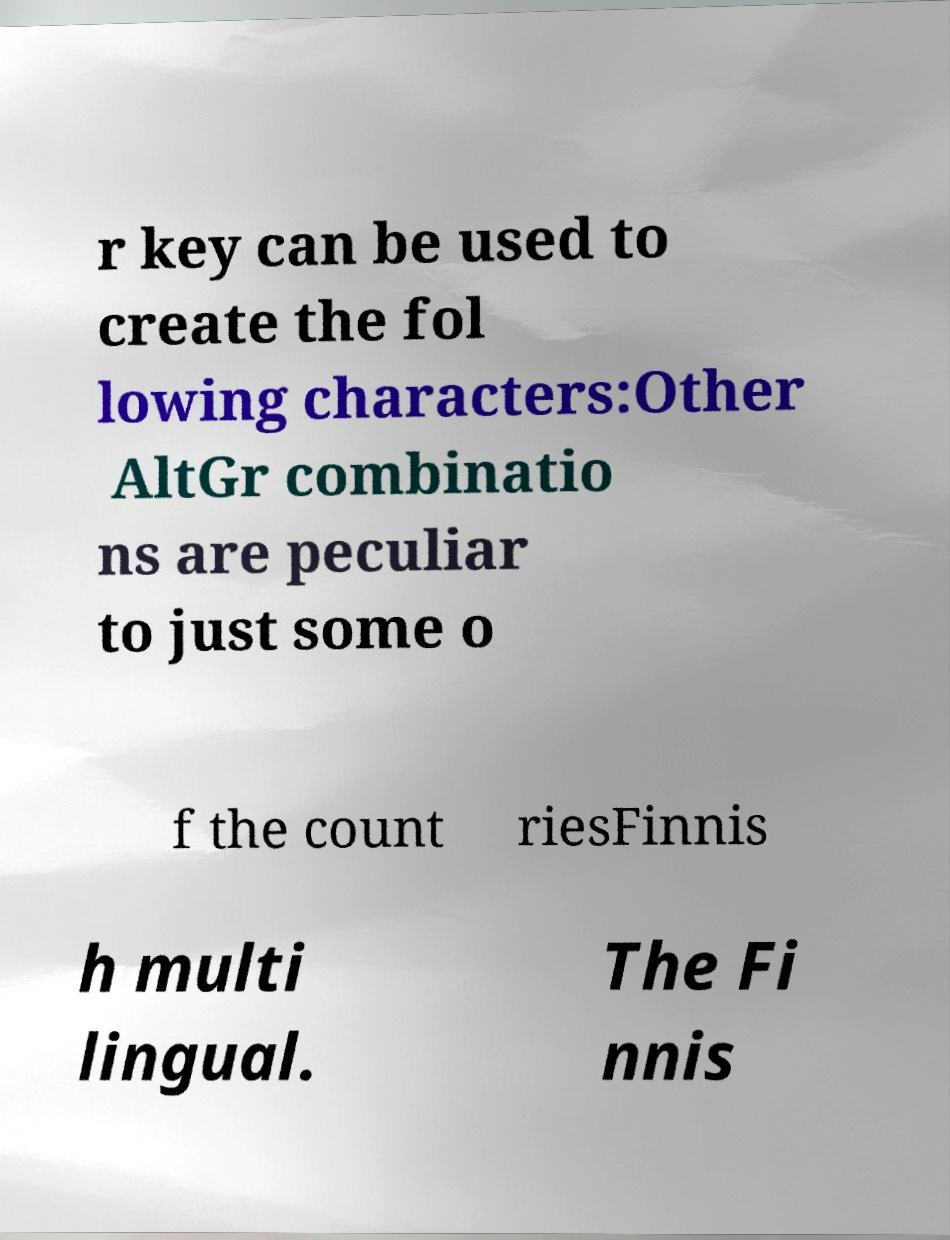Please identify and transcribe the text found in this image. r key can be used to create the fol lowing characters:Other AltGr combinatio ns are peculiar to just some o f the count riesFinnis h multi lingual. The Fi nnis 